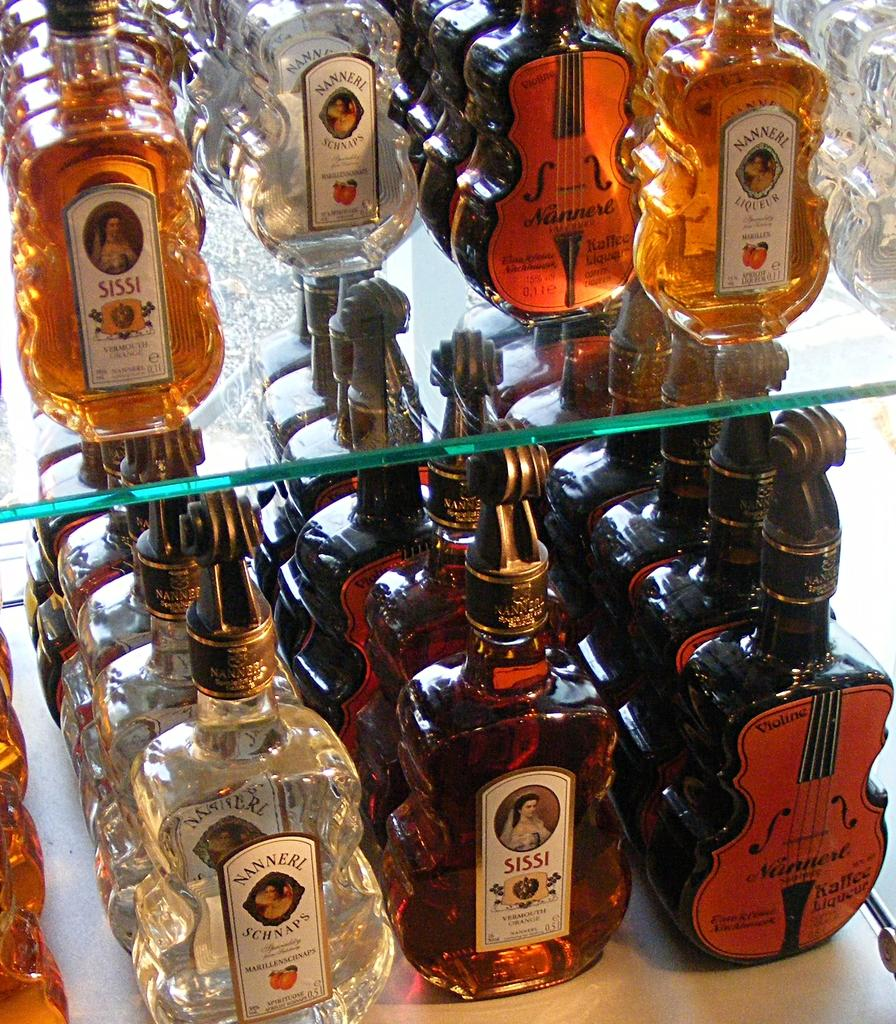<image>
Share a concise interpretation of the image provided. Bottles of alcohol on a shelf including one that says "Nannerl". 